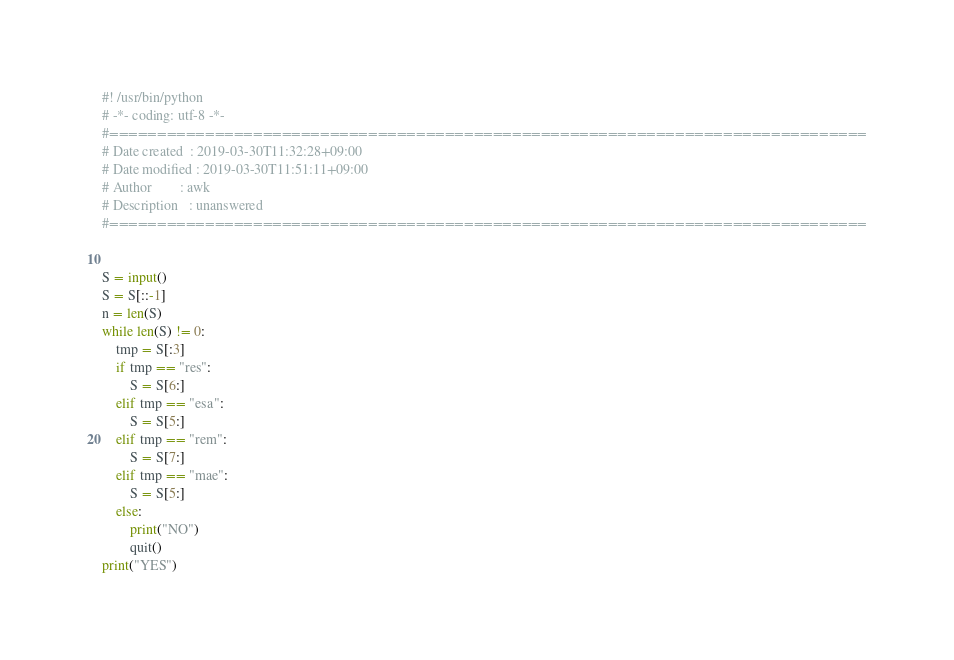<code> <loc_0><loc_0><loc_500><loc_500><_Python_>#! /usr/bin/python 
# -*- coding: utf-8 -*- 
#===============================================================================
# Date created  : 2019-03-30T11:32:28+09:00
# Date modified : 2019-03-30T11:51:11+09:00
# Author        : awk
# Description   : unanswered
#===============================================================================


S = input()
S = S[::-1] 
n = len(S)
while len(S) != 0:
    tmp = S[:3]
    if tmp == "res":
        S = S[6:]
    elif tmp == "esa":
        S = S[5:]
    elif tmp == "rem":
        S = S[7:]
    elif tmp == "mae":
        S = S[5:]
    else:
        print("NO")
        quit()
print("YES")
</code> 